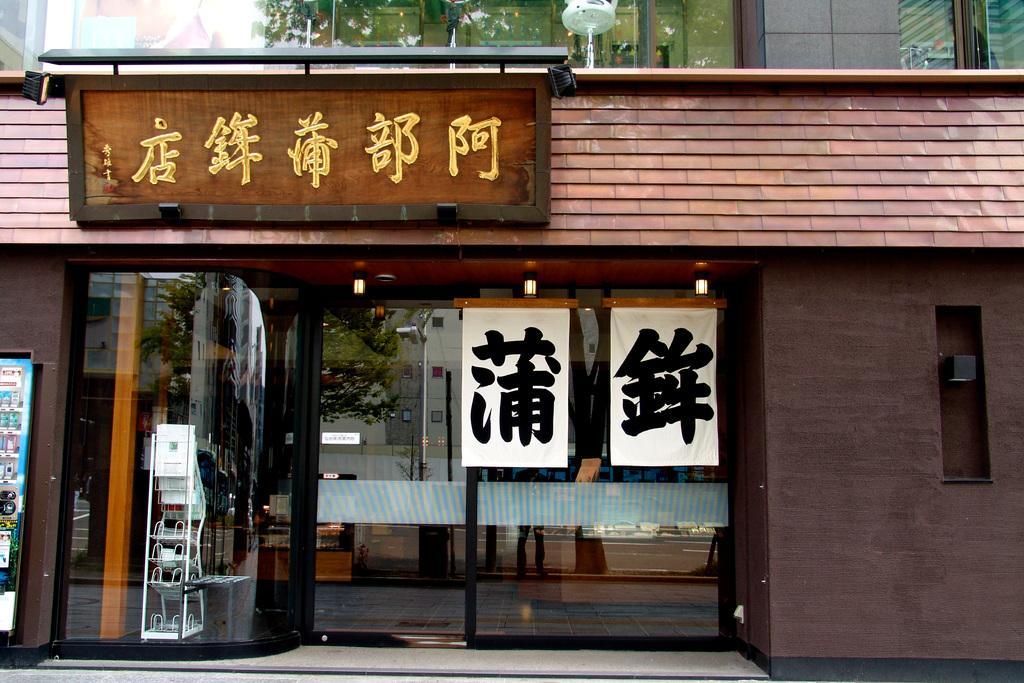Could you give a brief overview of what you see in this image? In a given image i can see a store that includes door,board,stand and some other objects. 